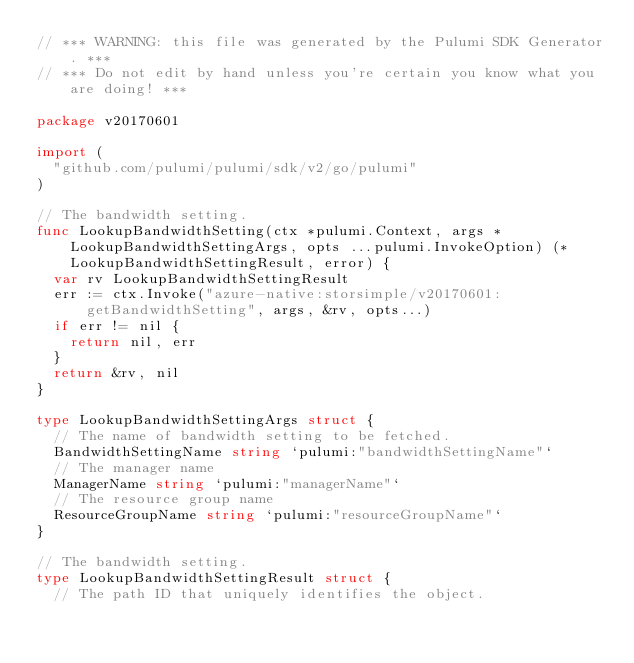Convert code to text. <code><loc_0><loc_0><loc_500><loc_500><_Go_>// *** WARNING: this file was generated by the Pulumi SDK Generator. ***
// *** Do not edit by hand unless you're certain you know what you are doing! ***

package v20170601

import (
	"github.com/pulumi/pulumi/sdk/v2/go/pulumi"
)

// The bandwidth setting.
func LookupBandwidthSetting(ctx *pulumi.Context, args *LookupBandwidthSettingArgs, opts ...pulumi.InvokeOption) (*LookupBandwidthSettingResult, error) {
	var rv LookupBandwidthSettingResult
	err := ctx.Invoke("azure-native:storsimple/v20170601:getBandwidthSetting", args, &rv, opts...)
	if err != nil {
		return nil, err
	}
	return &rv, nil
}

type LookupBandwidthSettingArgs struct {
	// The name of bandwidth setting to be fetched.
	BandwidthSettingName string `pulumi:"bandwidthSettingName"`
	// The manager name
	ManagerName string `pulumi:"managerName"`
	// The resource group name
	ResourceGroupName string `pulumi:"resourceGroupName"`
}

// The bandwidth setting.
type LookupBandwidthSettingResult struct {
	// The path ID that uniquely identifies the object.</code> 